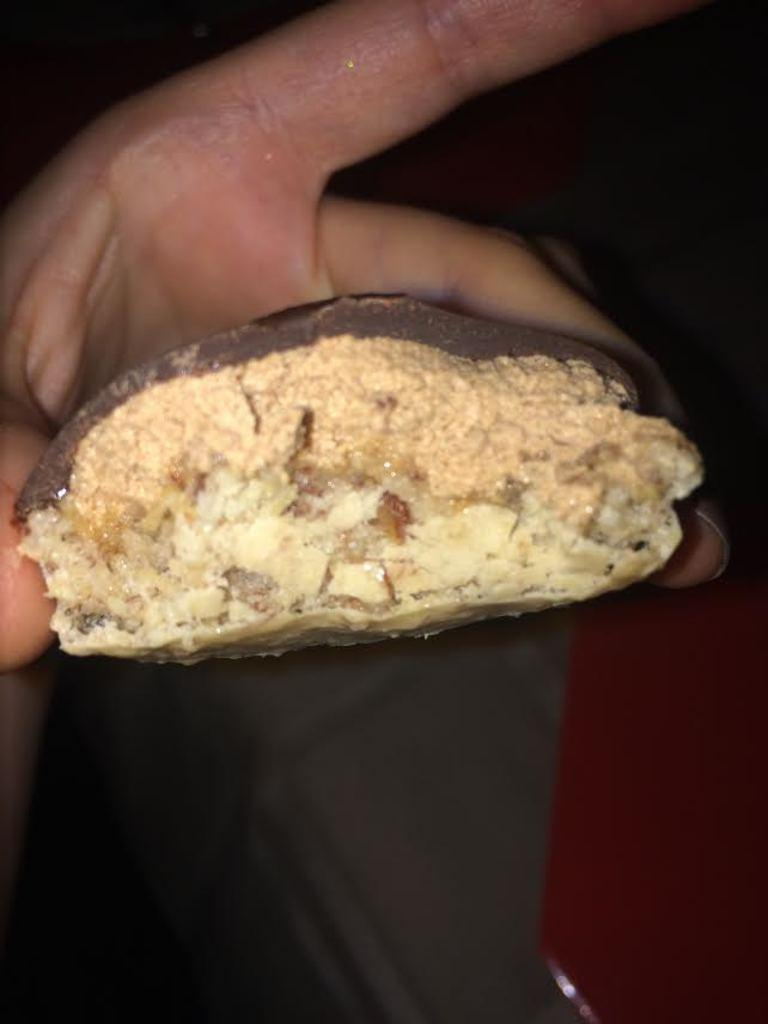What part of a person's body is visible in the image? There is a person's hand in the image. What is the hand holding? The hand is holding a chocolate. Is there a fan in the image that is being used to make the payment for the chocolate? There is no fan or payment mentioned in the image; it only shows a person's hand holding a chocolate. 